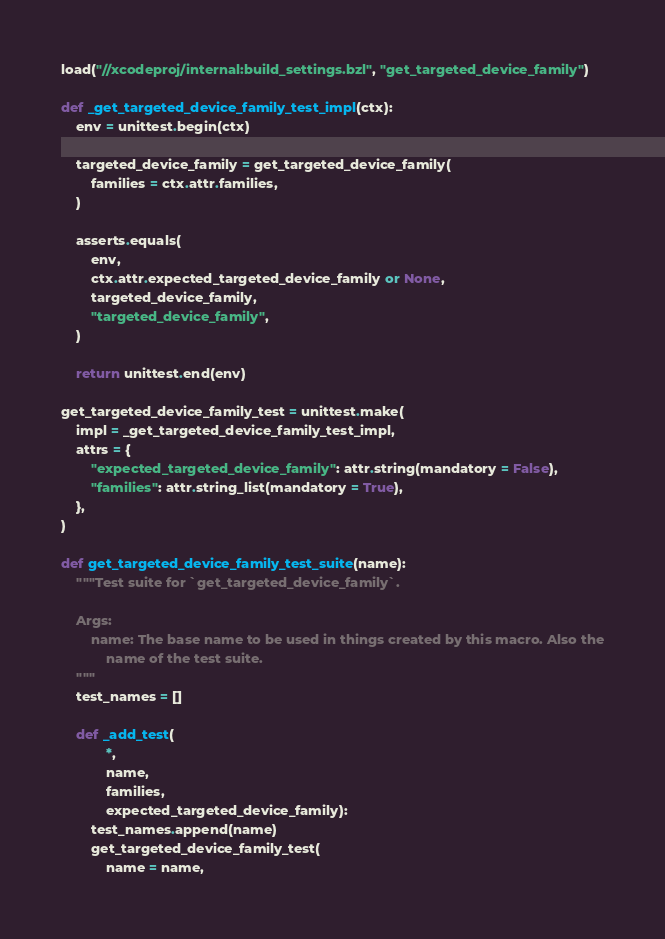<code> <loc_0><loc_0><loc_500><loc_500><_Python_>load("//xcodeproj/internal:build_settings.bzl", "get_targeted_device_family")

def _get_targeted_device_family_test_impl(ctx):
    env = unittest.begin(ctx)

    targeted_device_family = get_targeted_device_family(
        families = ctx.attr.families,
    )

    asserts.equals(
        env,
        ctx.attr.expected_targeted_device_family or None,
        targeted_device_family,
        "targeted_device_family",
    )

    return unittest.end(env)

get_targeted_device_family_test = unittest.make(
    impl = _get_targeted_device_family_test_impl,
    attrs = {
        "expected_targeted_device_family": attr.string(mandatory = False),
        "families": attr.string_list(mandatory = True),
    },
)

def get_targeted_device_family_test_suite(name):
    """Test suite for `get_targeted_device_family`.

    Args:
        name: The base name to be used in things created by this macro. Also the
            name of the test suite.
    """
    test_names = []

    def _add_test(
            *,
            name,
            families,
            expected_targeted_device_family):
        test_names.append(name)
        get_targeted_device_family_test(
            name = name,</code> 